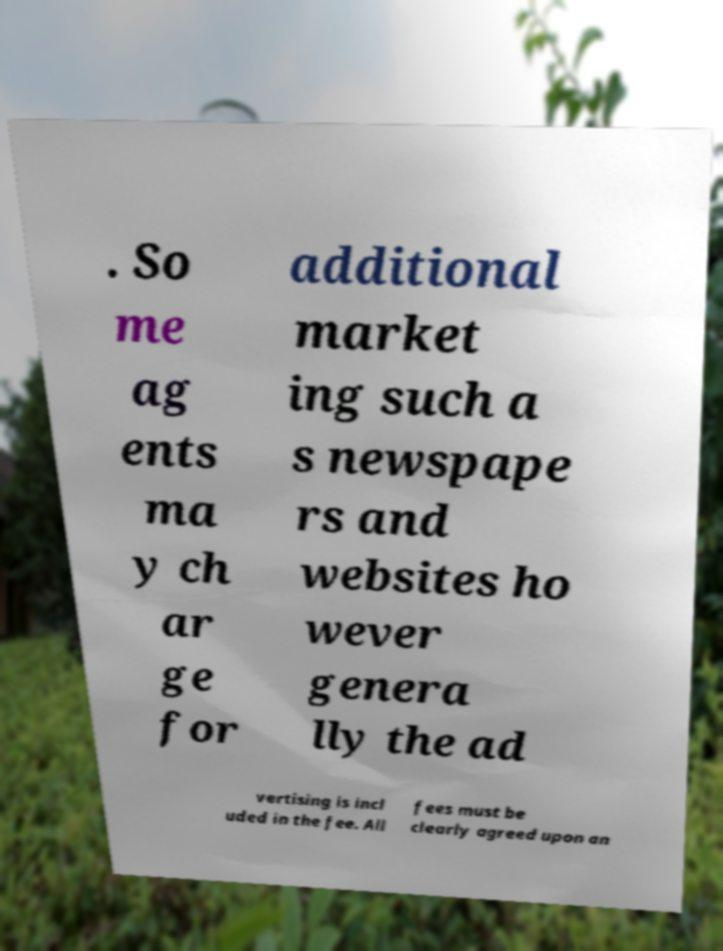There's text embedded in this image that I need extracted. Can you transcribe it verbatim? . So me ag ents ma y ch ar ge for additional market ing such a s newspape rs and websites ho wever genera lly the ad vertising is incl uded in the fee. All fees must be clearly agreed upon an 